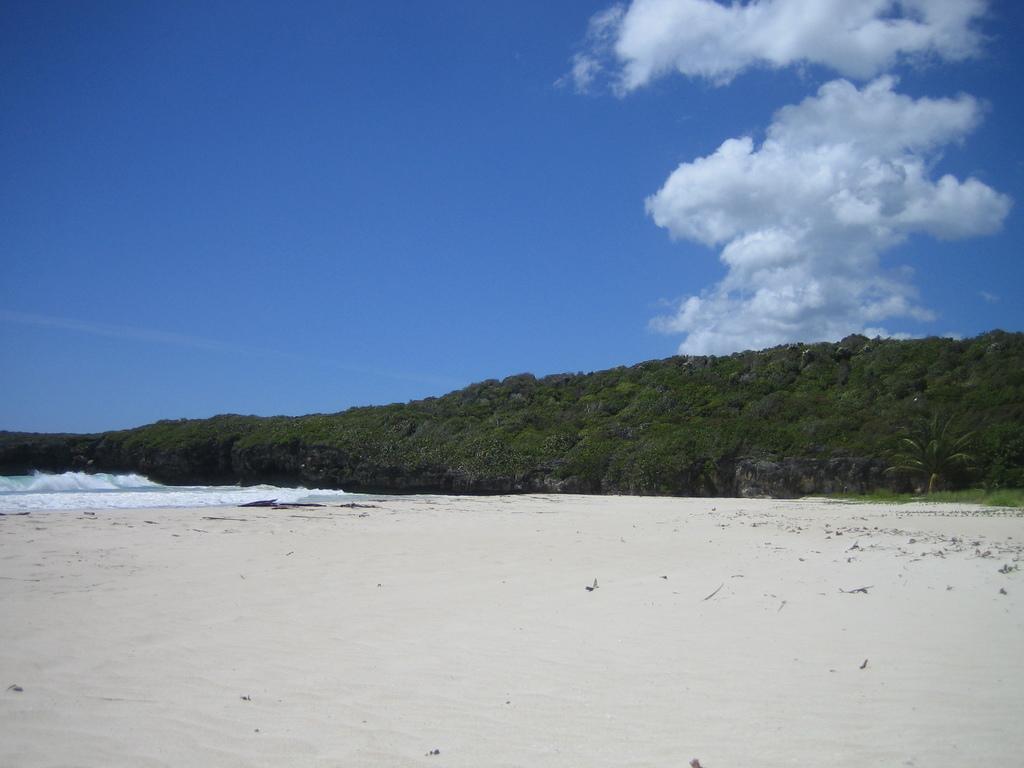Could you give a brief overview of what you see in this image? This image is taken in a beach. We can see many trees in this image. At the top there is sky with some clouds and at the bottom there is sand. 